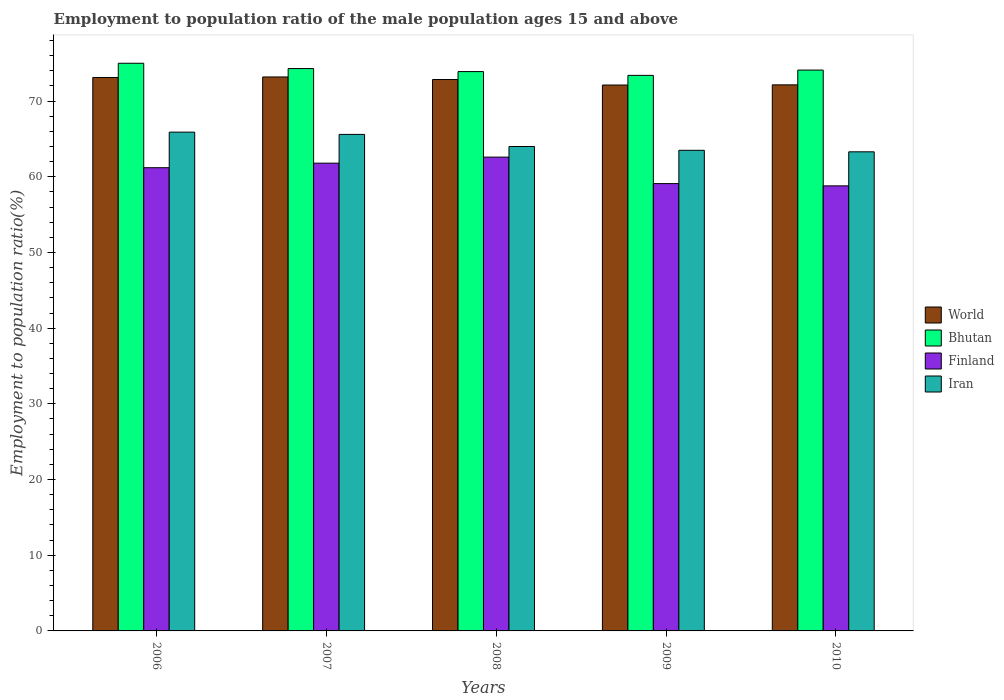Are the number of bars per tick equal to the number of legend labels?
Provide a short and direct response. Yes. Are the number of bars on each tick of the X-axis equal?
Offer a terse response. Yes. How many bars are there on the 3rd tick from the right?
Make the answer very short. 4. What is the label of the 1st group of bars from the left?
Offer a terse response. 2006. What is the employment to population ratio in World in 2010?
Your answer should be very brief. 72.15. Across all years, what is the maximum employment to population ratio in Bhutan?
Provide a short and direct response. 75. Across all years, what is the minimum employment to population ratio in Iran?
Offer a very short reply. 63.3. In which year was the employment to population ratio in Finland minimum?
Keep it short and to the point. 2010. What is the total employment to population ratio in Iran in the graph?
Your answer should be compact. 322.3. What is the difference between the employment to population ratio in Iran in 2007 and that in 2010?
Ensure brevity in your answer.  2.3. What is the difference between the employment to population ratio in Finland in 2007 and the employment to population ratio in World in 2009?
Offer a terse response. -10.32. What is the average employment to population ratio in World per year?
Your answer should be compact. 72.69. In the year 2008, what is the difference between the employment to population ratio in Bhutan and employment to population ratio in Finland?
Make the answer very short. 11.3. What is the ratio of the employment to population ratio in Bhutan in 2006 to that in 2010?
Your response must be concise. 1.01. What is the difference between the highest and the second highest employment to population ratio in Finland?
Offer a terse response. 0.8. What is the difference between the highest and the lowest employment to population ratio in Iran?
Give a very brief answer. 2.6. Is the sum of the employment to population ratio in Iran in 2007 and 2009 greater than the maximum employment to population ratio in Bhutan across all years?
Ensure brevity in your answer.  Yes. Is it the case that in every year, the sum of the employment to population ratio in Iran and employment to population ratio in Finland is greater than the sum of employment to population ratio in Bhutan and employment to population ratio in World?
Give a very brief answer. Yes. What does the 2nd bar from the left in 2009 represents?
Give a very brief answer. Bhutan. What does the 1st bar from the right in 2007 represents?
Give a very brief answer. Iran. Is it the case that in every year, the sum of the employment to population ratio in Iran and employment to population ratio in Bhutan is greater than the employment to population ratio in World?
Provide a succinct answer. Yes. How many years are there in the graph?
Your response must be concise. 5. What is the difference between two consecutive major ticks on the Y-axis?
Provide a succinct answer. 10. Are the values on the major ticks of Y-axis written in scientific E-notation?
Provide a succinct answer. No. Does the graph contain grids?
Your answer should be very brief. No. How many legend labels are there?
Offer a terse response. 4. What is the title of the graph?
Give a very brief answer. Employment to population ratio of the male population ages 15 and above. What is the label or title of the X-axis?
Provide a short and direct response. Years. What is the label or title of the Y-axis?
Provide a succinct answer. Employment to population ratio(%). What is the Employment to population ratio(%) in World in 2006?
Provide a succinct answer. 73.12. What is the Employment to population ratio(%) of Finland in 2006?
Provide a short and direct response. 61.2. What is the Employment to population ratio(%) of Iran in 2006?
Ensure brevity in your answer.  65.9. What is the Employment to population ratio(%) in World in 2007?
Provide a short and direct response. 73.19. What is the Employment to population ratio(%) in Bhutan in 2007?
Make the answer very short. 74.3. What is the Employment to population ratio(%) of Finland in 2007?
Offer a terse response. 61.8. What is the Employment to population ratio(%) of Iran in 2007?
Offer a very short reply. 65.6. What is the Employment to population ratio(%) in World in 2008?
Keep it short and to the point. 72.85. What is the Employment to population ratio(%) in Bhutan in 2008?
Keep it short and to the point. 73.9. What is the Employment to population ratio(%) of Finland in 2008?
Provide a succinct answer. 62.6. What is the Employment to population ratio(%) of Iran in 2008?
Make the answer very short. 64. What is the Employment to population ratio(%) of World in 2009?
Keep it short and to the point. 72.12. What is the Employment to population ratio(%) of Bhutan in 2009?
Give a very brief answer. 73.4. What is the Employment to population ratio(%) in Finland in 2009?
Your answer should be compact. 59.1. What is the Employment to population ratio(%) in Iran in 2009?
Provide a succinct answer. 63.5. What is the Employment to population ratio(%) in World in 2010?
Give a very brief answer. 72.15. What is the Employment to population ratio(%) in Bhutan in 2010?
Ensure brevity in your answer.  74.1. What is the Employment to population ratio(%) in Finland in 2010?
Offer a very short reply. 58.8. What is the Employment to population ratio(%) of Iran in 2010?
Give a very brief answer. 63.3. Across all years, what is the maximum Employment to population ratio(%) in World?
Make the answer very short. 73.19. Across all years, what is the maximum Employment to population ratio(%) of Bhutan?
Ensure brevity in your answer.  75. Across all years, what is the maximum Employment to population ratio(%) of Finland?
Provide a short and direct response. 62.6. Across all years, what is the maximum Employment to population ratio(%) of Iran?
Ensure brevity in your answer.  65.9. Across all years, what is the minimum Employment to population ratio(%) of World?
Your answer should be compact. 72.12. Across all years, what is the minimum Employment to population ratio(%) of Bhutan?
Offer a very short reply. 73.4. Across all years, what is the minimum Employment to population ratio(%) of Finland?
Ensure brevity in your answer.  58.8. Across all years, what is the minimum Employment to population ratio(%) in Iran?
Provide a short and direct response. 63.3. What is the total Employment to population ratio(%) in World in the graph?
Provide a succinct answer. 363.43. What is the total Employment to population ratio(%) of Bhutan in the graph?
Keep it short and to the point. 370.7. What is the total Employment to population ratio(%) of Finland in the graph?
Provide a short and direct response. 303.5. What is the total Employment to population ratio(%) in Iran in the graph?
Keep it short and to the point. 322.3. What is the difference between the Employment to population ratio(%) in World in 2006 and that in 2007?
Provide a succinct answer. -0.07. What is the difference between the Employment to population ratio(%) in Bhutan in 2006 and that in 2007?
Provide a short and direct response. 0.7. What is the difference between the Employment to population ratio(%) in Finland in 2006 and that in 2007?
Offer a terse response. -0.6. What is the difference between the Employment to population ratio(%) of World in 2006 and that in 2008?
Your response must be concise. 0.27. What is the difference between the Employment to population ratio(%) in Iran in 2006 and that in 2008?
Provide a succinct answer. 1.9. What is the difference between the Employment to population ratio(%) in World in 2006 and that in 2009?
Offer a very short reply. 1. What is the difference between the Employment to population ratio(%) in Iran in 2006 and that in 2009?
Your answer should be very brief. 2.4. What is the difference between the Employment to population ratio(%) in World in 2006 and that in 2010?
Provide a succinct answer. 0.97. What is the difference between the Employment to population ratio(%) in World in 2007 and that in 2008?
Keep it short and to the point. 0.34. What is the difference between the Employment to population ratio(%) of Iran in 2007 and that in 2008?
Your answer should be very brief. 1.6. What is the difference between the Employment to population ratio(%) in World in 2007 and that in 2009?
Provide a succinct answer. 1.07. What is the difference between the Employment to population ratio(%) in Iran in 2007 and that in 2009?
Your answer should be compact. 2.1. What is the difference between the Employment to population ratio(%) of World in 2007 and that in 2010?
Your answer should be compact. 1.04. What is the difference between the Employment to population ratio(%) of Finland in 2007 and that in 2010?
Give a very brief answer. 3. What is the difference between the Employment to population ratio(%) in Iran in 2007 and that in 2010?
Provide a succinct answer. 2.3. What is the difference between the Employment to population ratio(%) in World in 2008 and that in 2009?
Ensure brevity in your answer.  0.73. What is the difference between the Employment to population ratio(%) of Bhutan in 2008 and that in 2009?
Your answer should be very brief. 0.5. What is the difference between the Employment to population ratio(%) in World in 2008 and that in 2010?
Ensure brevity in your answer.  0.7. What is the difference between the Employment to population ratio(%) of Bhutan in 2008 and that in 2010?
Offer a terse response. -0.2. What is the difference between the Employment to population ratio(%) in Finland in 2008 and that in 2010?
Your response must be concise. 3.8. What is the difference between the Employment to population ratio(%) in Iran in 2008 and that in 2010?
Your answer should be compact. 0.7. What is the difference between the Employment to population ratio(%) in World in 2009 and that in 2010?
Make the answer very short. -0.02. What is the difference between the Employment to population ratio(%) of Bhutan in 2009 and that in 2010?
Your answer should be compact. -0.7. What is the difference between the Employment to population ratio(%) of Finland in 2009 and that in 2010?
Make the answer very short. 0.3. What is the difference between the Employment to population ratio(%) in World in 2006 and the Employment to population ratio(%) in Bhutan in 2007?
Your response must be concise. -1.18. What is the difference between the Employment to population ratio(%) of World in 2006 and the Employment to population ratio(%) of Finland in 2007?
Provide a succinct answer. 11.32. What is the difference between the Employment to population ratio(%) in World in 2006 and the Employment to population ratio(%) in Iran in 2007?
Make the answer very short. 7.52. What is the difference between the Employment to population ratio(%) in World in 2006 and the Employment to population ratio(%) in Bhutan in 2008?
Your response must be concise. -0.78. What is the difference between the Employment to population ratio(%) of World in 2006 and the Employment to population ratio(%) of Finland in 2008?
Offer a terse response. 10.52. What is the difference between the Employment to population ratio(%) in World in 2006 and the Employment to population ratio(%) in Iran in 2008?
Make the answer very short. 9.12. What is the difference between the Employment to population ratio(%) in Finland in 2006 and the Employment to population ratio(%) in Iran in 2008?
Your response must be concise. -2.8. What is the difference between the Employment to population ratio(%) of World in 2006 and the Employment to population ratio(%) of Bhutan in 2009?
Give a very brief answer. -0.28. What is the difference between the Employment to population ratio(%) of World in 2006 and the Employment to population ratio(%) of Finland in 2009?
Offer a terse response. 14.02. What is the difference between the Employment to population ratio(%) of World in 2006 and the Employment to population ratio(%) of Iran in 2009?
Keep it short and to the point. 9.62. What is the difference between the Employment to population ratio(%) in Finland in 2006 and the Employment to population ratio(%) in Iran in 2009?
Your response must be concise. -2.3. What is the difference between the Employment to population ratio(%) of World in 2006 and the Employment to population ratio(%) of Bhutan in 2010?
Give a very brief answer. -0.98. What is the difference between the Employment to population ratio(%) of World in 2006 and the Employment to population ratio(%) of Finland in 2010?
Your answer should be very brief. 14.32. What is the difference between the Employment to population ratio(%) in World in 2006 and the Employment to population ratio(%) in Iran in 2010?
Give a very brief answer. 9.82. What is the difference between the Employment to population ratio(%) in Finland in 2006 and the Employment to population ratio(%) in Iran in 2010?
Your answer should be compact. -2.1. What is the difference between the Employment to population ratio(%) in World in 2007 and the Employment to population ratio(%) in Bhutan in 2008?
Offer a terse response. -0.71. What is the difference between the Employment to population ratio(%) of World in 2007 and the Employment to population ratio(%) of Finland in 2008?
Keep it short and to the point. 10.59. What is the difference between the Employment to population ratio(%) in World in 2007 and the Employment to population ratio(%) in Iran in 2008?
Offer a terse response. 9.19. What is the difference between the Employment to population ratio(%) in Bhutan in 2007 and the Employment to population ratio(%) in Finland in 2008?
Your answer should be compact. 11.7. What is the difference between the Employment to population ratio(%) of Bhutan in 2007 and the Employment to population ratio(%) of Iran in 2008?
Your response must be concise. 10.3. What is the difference between the Employment to population ratio(%) in Finland in 2007 and the Employment to population ratio(%) in Iran in 2008?
Your answer should be very brief. -2.2. What is the difference between the Employment to population ratio(%) in World in 2007 and the Employment to population ratio(%) in Bhutan in 2009?
Your answer should be very brief. -0.21. What is the difference between the Employment to population ratio(%) of World in 2007 and the Employment to population ratio(%) of Finland in 2009?
Ensure brevity in your answer.  14.09. What is the difference between the Employment to population ratio(%) in World in 2007 and the Employment to population ratio(%) in Iran in 2009?
Your response must be concise. 9.69. What is the difference between the Employment to population ratio(%) of Bhutan in 2007 and the Employment to population ratio(%) of Iran in 2009?
Your answer should be compact. 10.8. What is the difference between the Employment to population ratio(%) in World in 2007 and the Employment to population ratio(%) in Bhutan in 2010?
Your answer should be compact. -0.91. What is the difference between the Employment to population ratio(%) in World in 2007 and the Employment to population ratio(%) in Finland in 2010?
Offer a terse response. 14.39. What is the difference between the Employment to population ratio(%) of World in 2007 and the Employment to population ratio(%) of Iran in 2010?
Offer a terse response. 9.89. What is the difference between the Employment to population ratio(%) of Bhutan in 2007 and the Employment to population ratio(%) of Finland in 2010?
Your response must be concise. 15.5. What is the difference between the Employment to population ratio(%) of Bhutan in 2007 and the Employment to population ratio(%) of Iran in 2010?
Ensure brevity in your answer.  11. What is the difference between the Employment to population ratio(%) in Finland in 2007 and the Employment to population ratio(%) in Iran in 2010?
Your response must be concise. -1.5. What is the difference between the Employment to population ratio(%) in World in 2008 and the Employment to population ratio(%) in Bhutan in 2009?
Keep it short and to the point. -0.55. What is the difference between the Employment to population ratio(%) of World in 2008 and the Employment to population ratio(%) of Finland in 2009?
Offer a very short reply. 13.75. What is the difference between the Employment to population ratio(%) of World in 2008 and the Employment to population ratio(%) of Iran in 2009?
Offer a terse response. 9.35. What is the difference between the Employment to population ratio(%) of Bhutan in 2008 and the Employment to population ratio(%) of Finland in 2009?
Provide a short and direct response. 14.8. What is the difference between the Employment to population ratio(%) in Finland in 2008 and the Employment to population ratio(%) in Iran in 2009?
Ensure brevity in your answer.  -0.9. What is the difference between the Employment to population ratio(%) of World in 2008 and the Employment to population ratio(%) of Bhutan in 2010?
Your answer should be very brief. -1.25. What is the difference between the Employment to population ratio(%) of World in 2008 and the Employment to population ratio(%) of Finland in 2010?
Your answer should be compact. 14.05. What is the difference between the Employment to population ratio(%) in World in 2008 and the Employment to population ratio(%) in Iran in 2010?
Your response must be concise. 9.55. What is the difference between the Employment to population ratio(%) of Bhutan in 2008 and the Employment to population ratio(%) of Finland in 2010?
Provide a succinct answer. 15.1. What is the difference between the Employment to population ratio(%) in World in 2009 and the Employment to population ratio(%) in Bhutan in 2010?
Ensure brevity in your answer.  -1.98. What is the difference between the Employment to population ratio(%) of World in 2009 and the Employment to population ratio(%) of Finland in 2010?
Keep it short and to the point. 13.32. What is the difference between the Employment to population ratio(%) in World in 2009 and the Employment to population ratio(%) in Iran in 2010?
Keep it short and to the point. 8.82. What is the average Employment to population ratio(%) of World per year?
Give a very brief answer. 72.69. What is the average Employment to population ratio(%) of Bhutan per year?
Provide a succinct answer. 74.14. What is the average Employment to population ratio(%) of Finland per year?
Your response must be concise. 60.7. What is the average Employment to population ratio(%) in Iran per year?
Provide a succinct answer. 64.46. In the year 2006, what is the difference between the Employment to population ratio(%) in World and Employment to population ratio(%) in Bhutan?
Offer a very short reply. -1.88. In the year 2006, what is the difference between the Employment to population ratio(%) of World and Employment to population ratio(%) of Finland?
Your response must be concise. 11.92. In the year 2006, what is the difference between the Employment to population ratio(%) of World and Employment to population ratio(%) of Iran?
Ensure brevity in your answer.  7.22. In the year 2006, what is the difference between the Employment to population ratio(%) in Bhutan and Employment to population ratio(%) in Iran?
Ensure brevity in your answer.  9.1. In the year 2006, what is the difference between the Employment to population ratio(%) of Finland and Employment to population ratio(%) of Iran?
Give a very brief answer. -4.7. In the year 2007, what is the difference between the Employment to population ratio(%) in World and Employment to population ratio(%) in Bhutan?
Offer a very short reply. -1.11. In the year 2007, what is the difference between the Employment to population ratio(%) of World and Employment to population ratio(%) of Finland?
Provide a short and direct response. 11.39. In the year 2007, what is the difference between the Employment to population ratio(%) in World and Employment to population ratio(%) in Iran?
Provide a short and direct response. 7.59. In the year 2007, what is the difference between the Employment to population ratio(%) of Bhutan and Employment to population ratio(%) of Finland?
Keep it short and to the point. 12.5. In the year 2007, what is the difference between the Employment to population ratio(%) of Finland and Employment to population ratio(%) of Iran?
Give a very brief answer. -3.8. In the year 2008, what is the difference between the Employment to population ratio(%) of World and Employment to population ratio(%) of Bhutan?
Keep it short and to the point. -1.05. In the year 2008, what is the difference between the Employment to population ratio(%) of World and Employment to population ratio(%) of Finland?
Offer a terse response. 10.25. In the year 2008, what is the difference between the Employment to population ratio(%) of World and Employment to population ratio(%) of Iran?
Your response must be concise. 8.85. In the year 2009, what is the difference between the Employment to population ratio(%) of World and Employment to population ratio(%) of Bhutan?
Your answer should be compact. -1.28. In the year 2009, what is the difference between the Employment to population ratio(%) of World and Employment to population ratio(%) of Finland?
Give a very brief answer. 13.02. In the year 2009, what is the difference between the Employment to population ratio(%) of World and Employment to population ratio(%) of Iran?
Provide a short and direct response. 8.62. In the year 2009, what is the difference between the Employment to population ratio(%) in Bhutan and Employment to population ratio(%) in Finland?
Give a very brief answer. 14.3. In the year 2009, what is the difference between the Employment to population ratio(%) of Finland and Employment to population ratio(%) of Iran?
Your response must be concise. -4.4. In the year 2010, what is the difference between the Employment to population ratio(%) in World and Employment to population ratio(%) in Bhutan?
Provide a short and direct response. -1.95. In the year 2010, what is the difference between the Employment to population ratio(%) of World and Employment to population ratio(%) of Finland?
Your answer should be very brief. 13.35. In the year 2010, what is the difference between the Employment to population ratio(%) of World and Employment to population ratio(%) of Iran?
Give a very brief answer. 8.85. In the year 2010, what is the difference between the Employment to population ratio(%) in Finland and Employment to population ratio(%) in Iran?
Your response must be concise. -4.5. What is the ratio of the Employment to population ratio(%) in Bhutan in 2006 to that in 2007?
Offer a very short reply. 1.01. What is the ratio of the Employment to population ratio(%) in Finland in 2006 to that in 2007?
Keep it short and to the point. 0.99. What is the ratio of the Employment to population ratio(%) in World in 2006 to that in 2008?
Offer a terse response. 1. What is the ratio of the Employment to population ratio(%) of Bhutan in 2006 to that in 2008?
Your answer should be compact. 1.01. What is the ratio of the Employment to population ratio(%) of Finland in 2006 to that in 2008?
Ensure brevity in your answer.  0.98. What is the ratio of the Employment to population ratio(%) of Iran in 2006 to that in 2008?
Give a very brief answer. 1.03. What is the ratio of the Employment to population ratio(%) in World in 2006 to that in 2009?
Your response must be concise. 1.01. What is the ratio of the Employment to population ratio(%) in Bhutan in 2006 to that in 2009?
Ensure brevity in your answer.  1.02. What is the ratio of the Employment to population ratio(%) of Finland in 2006 to that in 2009?
Offer a very short reply. 1.04. What is the ratio of the Employment to population ratio(%) in Iran in 2006 to that in 2009?
Offer a terse response. 1.04. What is the ratio of the Employment to population ratio(%) in World in 2006 to that in 2010?
Provide a succinct answer. 1.01. What is the ratio of the Employment to population ratio(%) of Bhutan in 2006 to that in 2010?
Provide a succinct answer. 1.01. What is the ratio of the Employment to population ratio(%) in Finland in 2006 to that in 2010?
Provide a succinct answer. 1.04. What is the ratio of the Employment to population ratio(%) of Iran in 2006 to that in 2010?
Ensure brevity in your answer.  1.04. What is the ratio of the Employment to population ratio(%) in Bhutan in 2007 to that in 2008?
Keep it short and to the point. 1.01. What is the ratio of the Employment to population ratio(%) in Finland in 2007 to that in 2008?
Your response must be concise. 0.99. What is the ratio of the Employment to population ratio(%) in Iran in 2007 to that in 2008?
Offer a terse response. 1.02. What is the ratio of the Employment to population ratio(%) of World in 2007 to that in 2009?
Your answer should be compact. 1.01. What is the ratio of the Employment to population ratio(%) in Bhutan in 2007 to that in 2009?
Your answer should be very brief. 1.01. What is the ratio of the Employment to population ratio(%) of Finland in 2007 to that in 2009?
Ensure brevity in your answer.  1.05. What is the ratio of the Employment to population ratio(%) of Iran in 2007 to that in 2009?
Keep it short and to the point. 1.03. What is the ratio of the Employment to population ratio(%) in World in 2007 to that in 2010?
Provide a short and direct response. 1.01. What is the ratio of the Employment to population ratio(%) of Bhutan in 2007 to that in 2010?
Your response must be concise. 1. What is the ratio of the Employment to population ratio(%) of Finland in 2007 to that in 2010?
Provide a succinct answer. 1.05. What is the ratio of the Employment to population ratio(%) in Iran in 2007 to that in 2010?
Your response must be concise. 1.04. What is the ratio of the Employment to population ratio(%) in Bhutan in 2008 to that in 2009?
Provide a short and direct response. 1.01. What is the ratio of the Employment to population ratio(%) of Finland in 2008 to that in 2009?
Make the answer very short. 1.06. What is the ratio of the Employment to population ratio(%) in Iran in 2008 to that in 2009?
Your answer should be very brief. 1.01. What is the ratio of the Employment to population ratio(%) in World in 2008 to that in 2010?
Ensure brevity in your answer.  1.01. What is the ratio of the Employment to population ratio(%) in Finland in 2008 to that in 2010?
Make the answer very short. 1.06. What is the ratio of the Employment to population ratio(%) in Iran in 2008 to that in 2010?
Your response must be concise. 1.01. What is the ratio of the Employment to population ratio(%) of Bhutan in 2009 to that in 2010?
Offer a very short reply. 0.99. What is the difference between the highest and the second highest Employment to population ratio(%) in World?
Your response must be concise. 0.07. What is the difference between the highest and the second highest Employment to population ratio(%) in Finland?
Offer a very short reply. 0.8. What is the difference between the highest and the lowest Employment to population ratio(%) of World?
Provide a short and direct response. 1.07. What is the difference between the highest and the lowest Employment to population ratio(%) in Bhutan?
Your response must be concise. 1.6. What is the difference between the highest and the lowest Employment to population ratio(%) in Finland?
Offer a terse response. 3.8. 